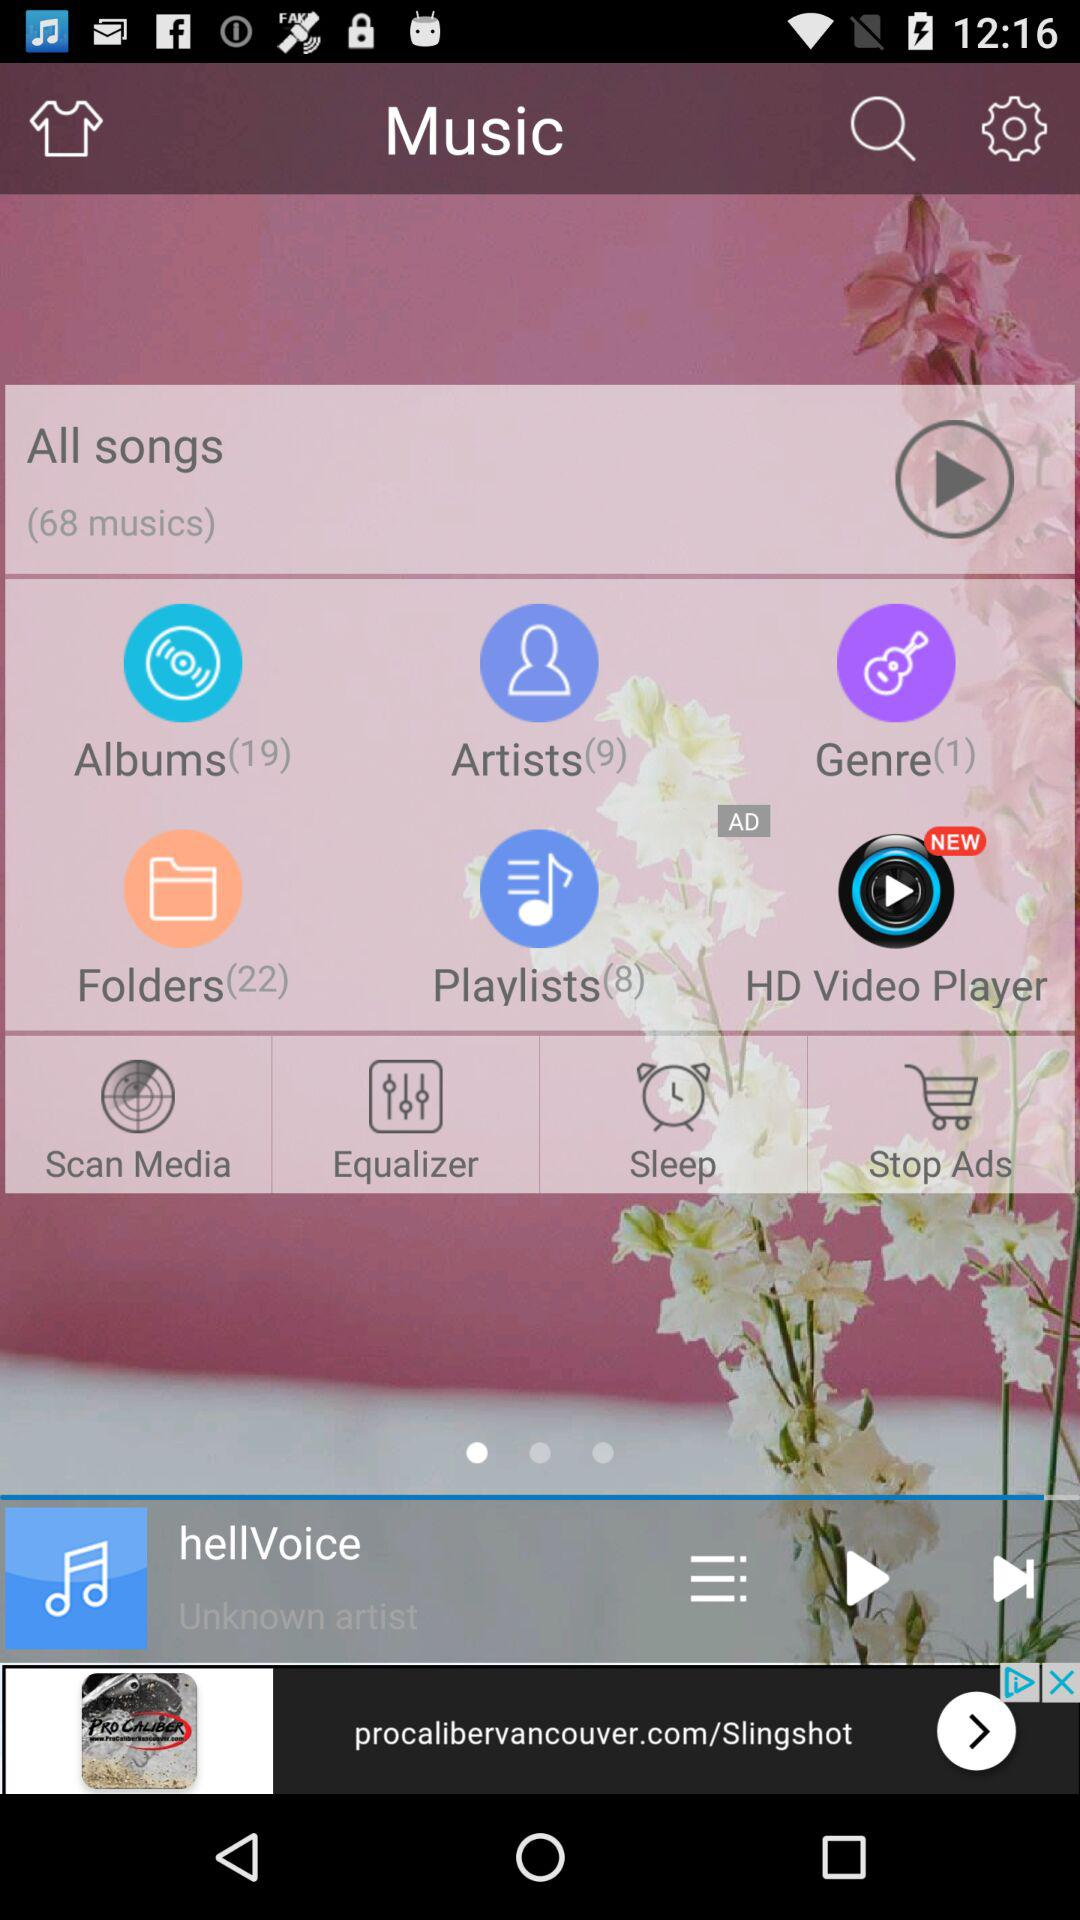What song was last played? The last played song was "hellVoice". 